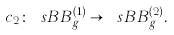<formula> <loc_0><loc_0><loc_500><loc_500>c _ { 2 } \colon \ s B B _ { g } ^ { ( 1 ) } \to \ s B B _ { g } ^ { ( 2 ) } .</formula> 